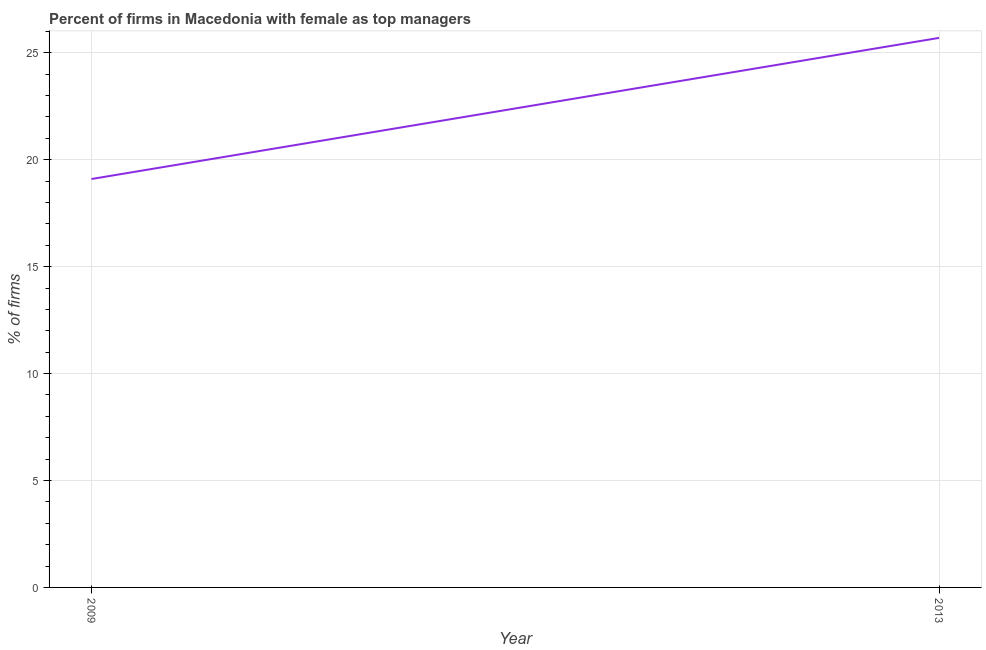What is the percentage of firms with female as top manager in 2013?
Provide a succinct answer. 25.7. Across all years, what is the maximum percentage of firms with female as top manager?
Your answer should be very brief. 25.7. Across all years, what is the minimum percentage of firms with female as top manager?
Your answer should be compact. 19.1. In which year was the percentage of firms with female as top manager maximum?
Give a very brief answer. 2013. What is the sum of the percentage of firms with female as top manager?
Keep it short and to the point. 44.8. What is the difference between the percentage of firms with female as top manager in 2009 and 2013?
Your response must be concise. -6.6. What is the average percentage of firms with female as top manager per year?
Provide a short and direct response. 22.4. What is the median percentage of firms with female as top manager?
Ensure brevity in your answer.  22.4. What is the ratio of the percentage of firms with female as top manager in 2009 to that in 2013?
Offer a very short reply. 0.74. How many lines are there?
Your response must be concise. 1. How many years are there in the graph?
Give a very brief answer. 2. What is the difference between two consecutive major ticks on the Y-axis?
Offer a very short reply. 5. Are the values on the major ticks of Y-axis written in scientific E-notation?
Give a very brief answer. No. Does the graph contain any zero values?
Your answer should be compact. No. What is the title of the graph?
Your response must be concise. Percent of firms in Macedonia with female as top managers. What is the label or title of the Y-axis?
Ensure brevity in your answer.  % of firms. What is the % of firms of 2013?
Keep it short and to the point. 25.7. What is the ratio of the % of firms in 2009 to that in 2013?
Offer a very short reply. 0.74. 